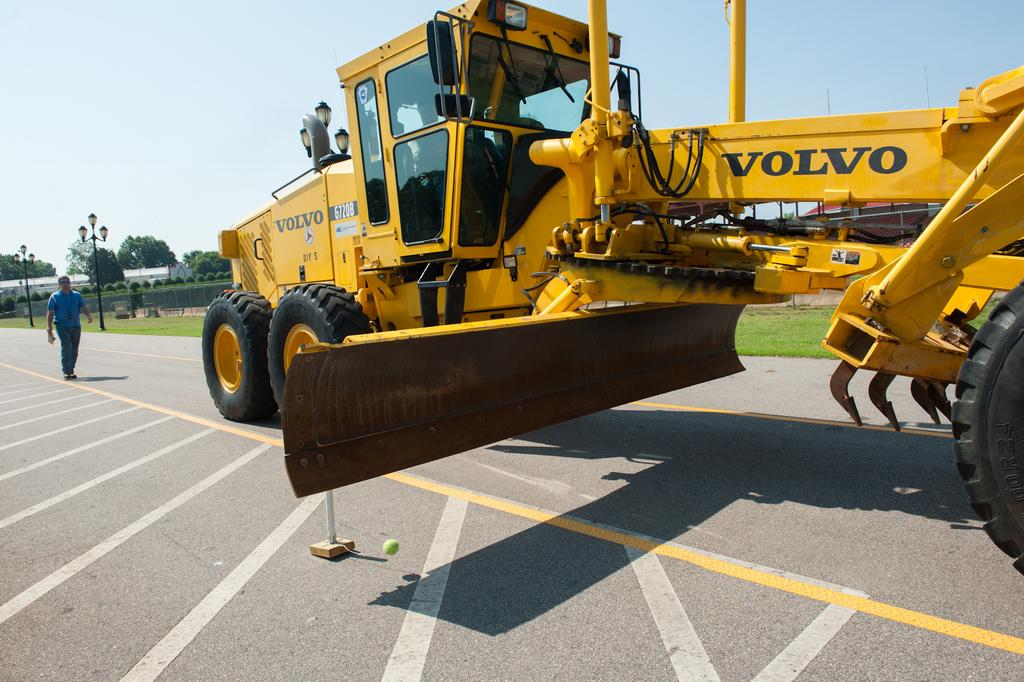<image>
Relay a brief, clear account of the picture shown. the volvo piece of machinery is yellow and huge 